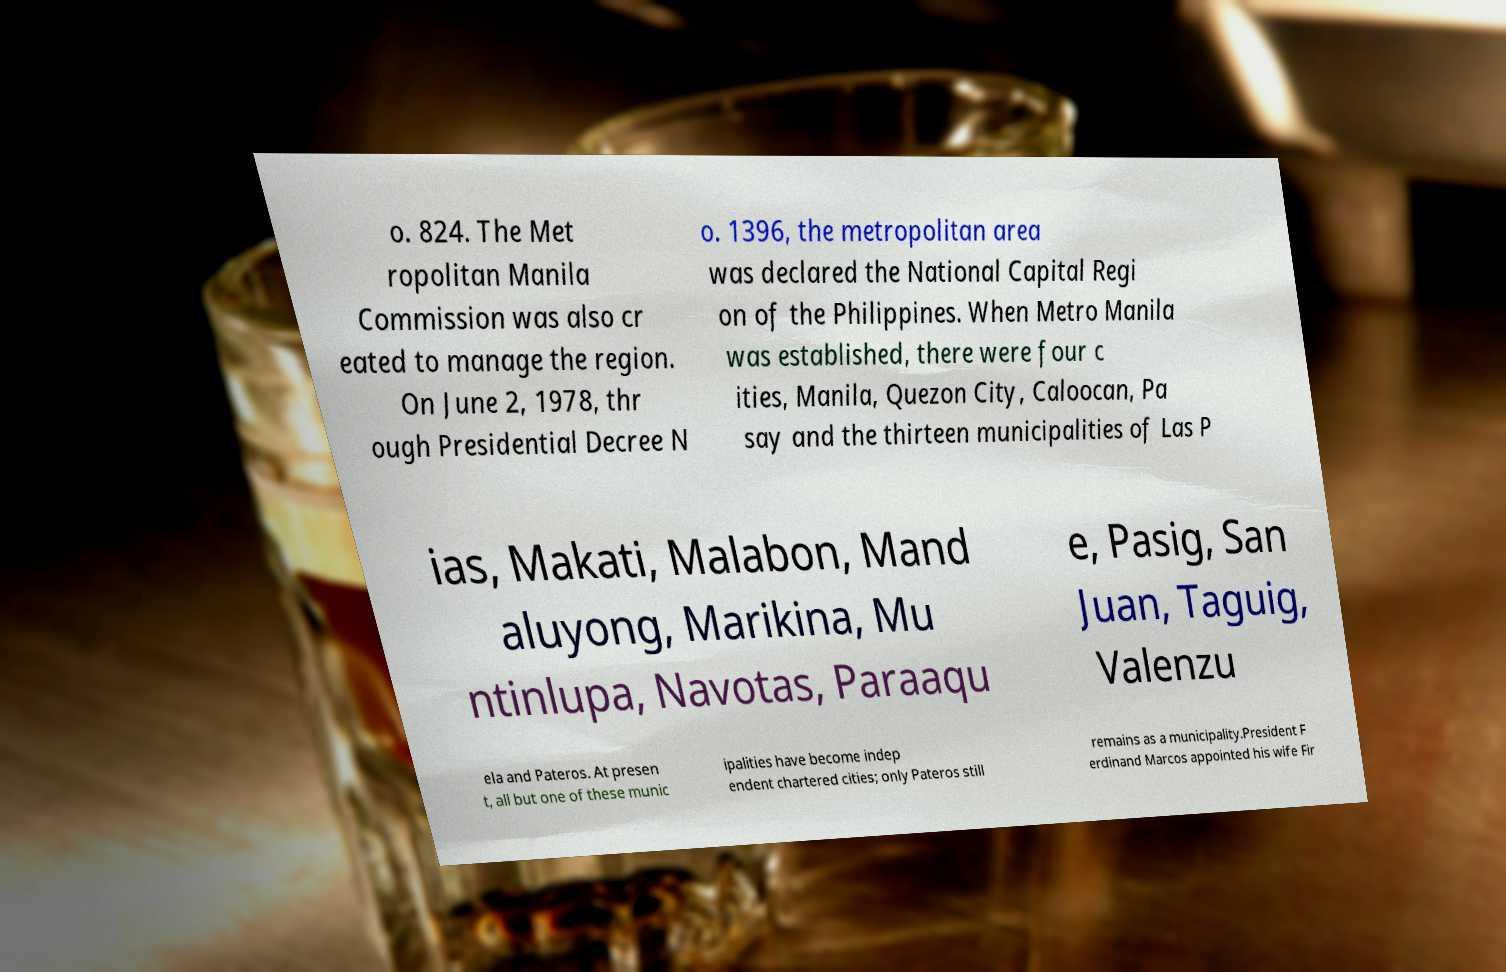Could you extract and type out the text from this image? o. 824. The Met ropolitan Manila Commission was also cr eated to manage the region. On June 2, 1978, thr ough Presidential Decree N o. 1396, the metropolitan area was declared the National Capital Regi on of the Philippines. When Metro Manila was established, there were four c ities, Manila, Quezon City, Caloocan, Pa say and the thirteen municipalities of Las P ias, Makati, Malabon, Mand aluyong, Marikina, Mu ntinlupa, Navotas, Paraaqu e, Pasig, San Juan, Taguig, Valenzu ela and Pateros. At presen t, all but one of these munic ipalities have become indep endent chartered cities; only Pateros still remains as a municipality.President F erdinand Marcos appointed his wife Fir 